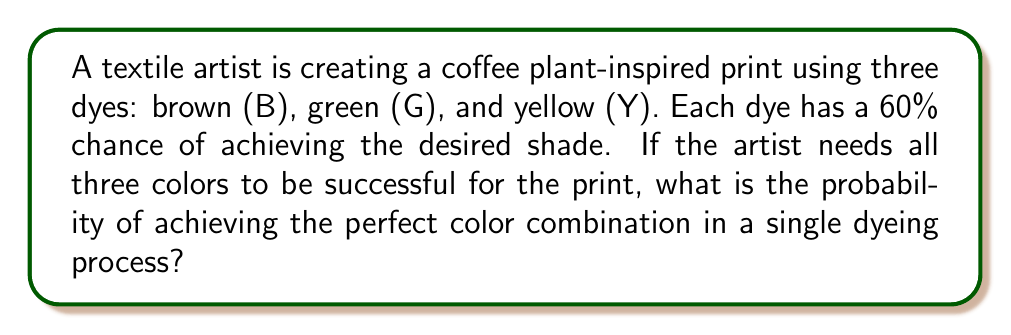Help me with this question. Let's approach this step-by-step:

1) For each individual dye, the probability of success is 60% or 0.6.

2) We need all three dyes to be successful simultaneously. This is an example of independent events, where the outcome of one does not affect the others.

3) When we need multiple independent events to all occur, we multiply their individual probabilities.

4) Let's define our events:
   $P(B)$ = Probability of brown dye success = 0.6
   $P(G)$ = Probability of green dye success = 0.6
   $P(Y)$ = Probability of yellow dye success = 0.6

5) The probability of all three being successful is:

   $$P(\text{all successful}) = P(B) \times P(G) \times P(Y)$$

6) Substituting the values:

   $$P(\text{all successful}) = 0.6 \times 0.6 \times 0.6 = 0.6^3 = 0.216$$

7) Converting to a percentage:

   $$0.216 \times 100\% = 21.6\%$$

Therefore, the probability of achieving the perfect color combination in a single dyeing process is 21.6%.
Answer: 21.6% 